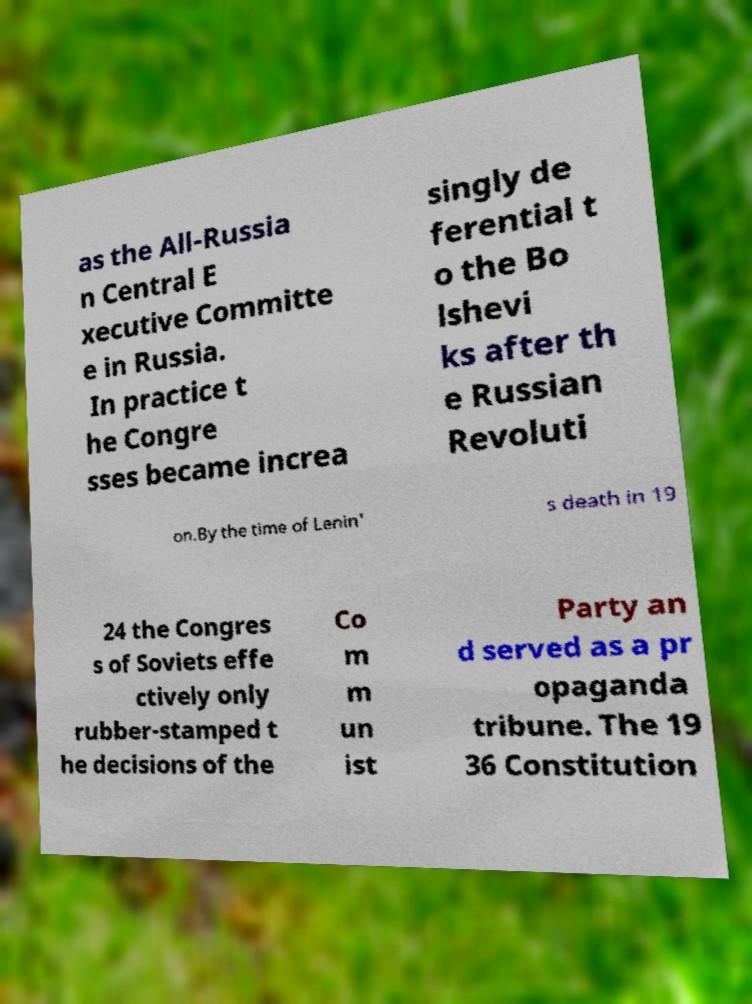Please read and relay the text visible in this image. What does it say? as the All-Russia n Central E xecutive Committe e in Russia. In practice t he Congre sses became increa singly de ferential t o the Bo lshevi ks after th e Russian Revoluti on.By the time of Lenin' s death in 19 24 the Congres s of Soviets effe ctively only rubber-stamped t he decisions of the Co m m un ist Party an d served as a pr opaganda tribune. The 19 36 Constitution 